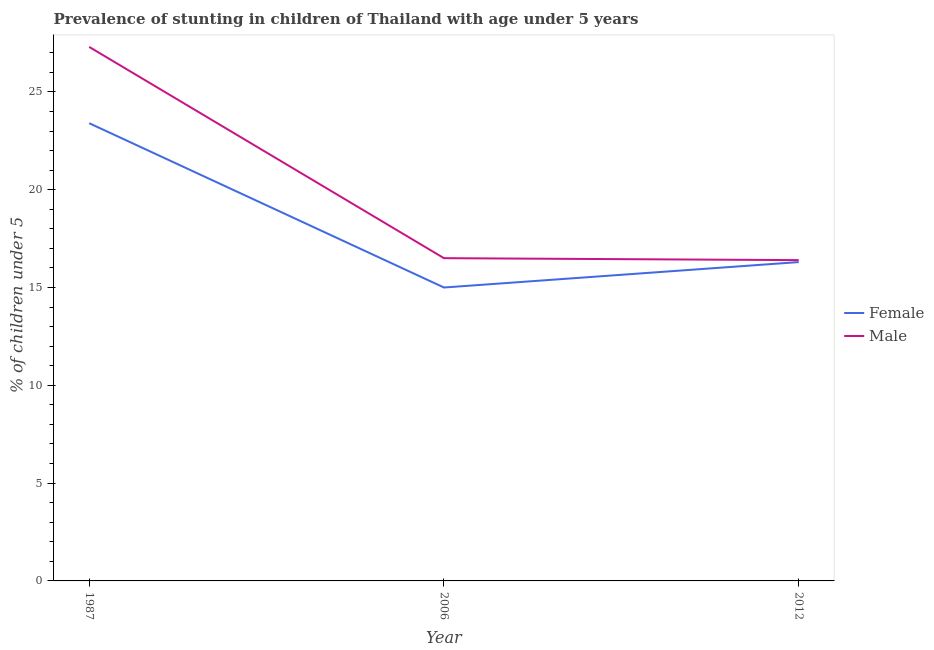Does the line corresponding to percentage of stunted female children intersect with the line corresponding to percentage of stunted male children?
Make the answer very short. No. What is the percentage of stunted female children in 2012?
Keep it short and to the point. 16.3. Across all years, what is the maximum percentage of stunted male children?
Offer a very short reply. 27.3. In which year was the percentage of stunted male children maximum?
Offer a very short reply. 1987. What is the total percentage of stunted male children in the graph?
Provide a succinct answer. 60.2. What is the difference between the percentage of stunted female children in 1987 and that in 2012?
Offer a very short reply. 7.1. What is the difference between the percentage of stunted male children in 1987 and the percentage of stunted female children in 2006?
Your answer should be compact. 12.3. What is the average percentage of stunted female children per year?
Ensure brevity in your answer.  18.23. In the year 2012, what is the difference between the percentage of stunted male children and percentage of stunted female children?
Give a very brief answer. 0.1. What is the ratio of the percentage of stunted male children in 1987 to that in 2006?
Your answer should be compact. 1.65. Is the percentage of stunted male children in 2006 less than that in 2012?
Your answer should be very brief. No. Is the difference between the percentage of stunted female children in 1987 and 2012 greater than the difference between the percentage of stunted male children in 1987 and 2012?
Keep it short and to the point. No. What is the difference between the highest and the second highest percentage of stunted female children?
Your answer should be very brief. 7.1. What is the difference between the highest and the lowest percentage of stunted female children?
Keep it short and to the point. 8.4. In how many years, is the percentage of stunted female children greater than the average percentage of stunted female children taken over all years?
Offer a terse response. 1. Is the percentage of stunted female children strictly less than the percentage of stunted male children over the years?
Offer a very short reply. Yes. How many lines are there?
Provide a short and direct response. 2. How many years are there in the graph?
Provide a short and direct response. 3. Are the values on the major ticks of Y-axis written in scientific E-notation?
Keep it short and to the point. No. How many legend labels are there?
Make the answer very short. 2. What is the title of the graph?
Your response must be concise. Prevalence of stunting in children of Thailand with age under 5 years. What is the label or title of the X-axis?
Ensure brevity in your answer.  Year. What is the label or title of the Y-axis?
Give a very brief answer.  % of children under 5. What is the  % of children under 5 of Female in 1987?
Keep it short and to the point. 23.4. What is the  % of children under 5 of Male in 1987?
Give a very brief answer. 27.3. What is the  % of children under 5 of Female in 2006?
Your response must be concise. 15. What is the  % of children under 5 of Female in 2012?
Your answer should be very brief. 16.3. What is the  % of children under 5 in Male in 2012?
Your answer should be compact. 16.4. Across all years, what is the maximum  % of children under 5 of Female?
Ensure brevity in your answer.  23.4. Across all years, what is the maximum  % of children under 5 in Male?
Provide a succinct answer. 27.3. Across all years, what is the minimum  % of children under 5 of Male?
Offer a very short reply. 16.4. What is the total  % of children under 5 in Female in the graph?
Offer a terse response. 54.7. What is the total  % of children under 5 in Male in the graph?
Make the answer very short. 60.2. What is the difference between the  % of children under 5 in Male in 1987 and that in 2006?
Provide a succinct answer. 10.8. What is the difference between the  % of children under 5 in Male in 2006 and that in 2012?
Provide a succinct answer. 0.1. What is the difference between the  % of children under 5 of Female in 1987 and the  % of children under 5 of Male in 2006?
Give a very brief answer. 6.9. What is the average  % of children under 5 in Female per year?
Offer a terse response. 18.23. What is the average  % of children under 5 in Male per year?
Your answer should be compact. 20.07. In the year 2012, what is the difference between the  % of children under 5 of Female and  % of children under 5 of Male?
Offer a terse response. -0.1. What is the ratio of the  % of children under 5 in Female in 1987 to that in 2006?
Give a very brief answer. 1.56. What is the ratio of the  % of children under 5 of Male in 1987 to that in 2006?
Keep it short and to the point. 1.65. What is the ratio of the  % of children under 5 of Female in 1987 to that in 2012?
Your response must be concise. 1.44. What is the ratio of the  % of children under 5 of Male in 1987 to that in 2012?
Keep it short and to the point. 1.66. What is the ratio of the  % of children under 5 in Female in 2006 to that in 2012?
Provide a succinct answer. 0.92. What is the ratio of the  % of children under 5 in Male in 2006 to that in 2012?
Provide a short and direct response. 1.01. What is the difference between the highest and the second highest  % of children under 5 in Female?
Give a very brief answer. 7.1. What is the difference between the highest and the second highest  % of children under 5 in Male?
Make the answer very short. 10.8. What is the difference between the highest and the lowest  % of children under 5 of Male?
Ensure brevity in your answer.  10.9. 